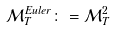Convert formula to latex. <formula><loc_0><loc_0><loc_500><loc_500>\mathcal { M } ^ { E u l e r } _ { T } \colon = \mathcal { M } _ { T } ^ { 2 }</formula> 